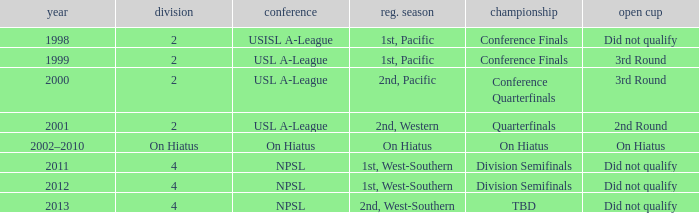Which playoffs took place during 2011? Division Semifinals. 